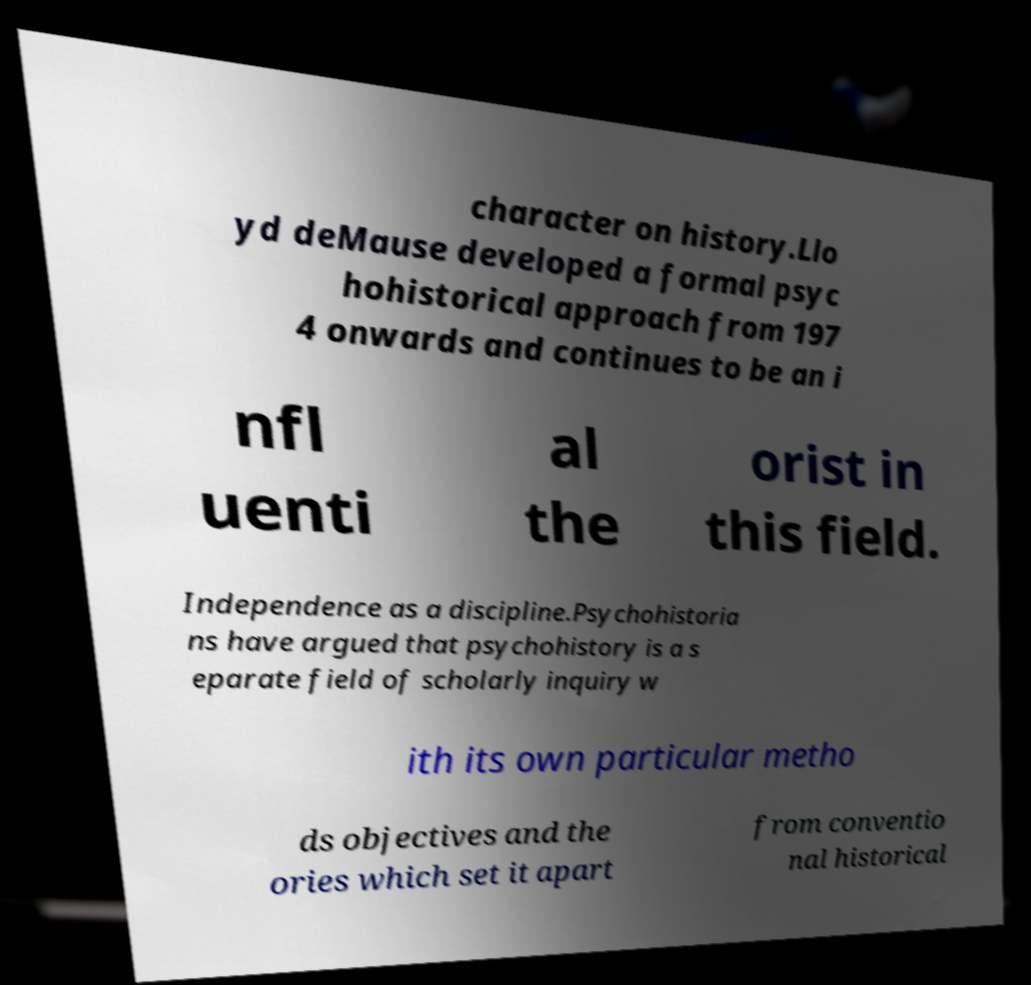Please read and relay the text visible in this image. What does it say? character on history.Llo yd deMause developed a formal psyc hohistorical approach from 197 4 onwards and continues to be an i nfl uenti al the orist in this field. Independence as a discipline.Psychohistoria ns have argued that psychohistory is a s eparate field of scholarly inquiry w ith its own particular metho ds objectives and the ories which set it apart from conventio nal historical 